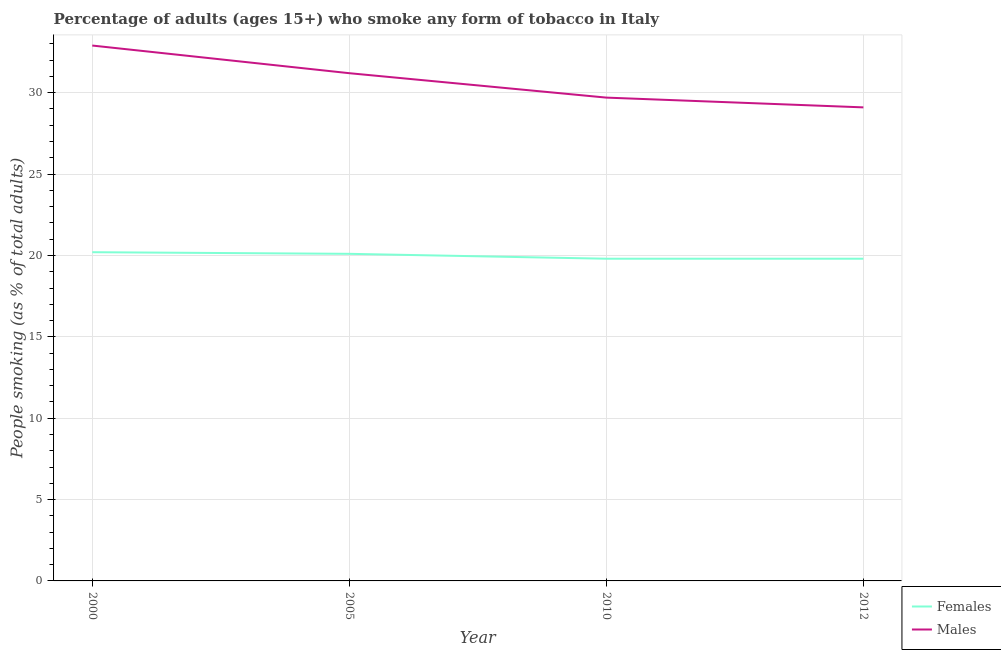How many different coloured lines are there?
Keep it short and to the point. 2. What is the percentage of males who smoke in 2010?
Your answer should be very brief. 29.7. Across all years, what is the maximum percentage of females who smoke?
Keep it short and to the point. 20.2. Across all years, what is the minimum percentage of males who smoke?
Make the answer very short. 29.1. In which year was the percentage of males who smoke maximum?
Offer a terse response. 2000. In which year was the percentage of females who smoke minimum?
Your answer should be compact. 2010. What is the total percentage of males who smoke in the graph?
Provide a succinct answer. 122.9. What is the difference between the percentage of males who smoke in 2000 and that in 2010?
Your answer should be very brief. 3.2. What is the difference between the percentage of males who smoke in 2012 and the percentage of females who smoke in 2000?
Provide a short and direct response. 8.9. What is the average percentage of females who smoke per year?
Offer a very short reply. 19.97. In the year 2010, what is the difference between the percentage of females who smoke and percentage of males who smoke?
Offer a terse response. -9.9. In how many years, is the percentage of males who smoke greater than 9 %?
Provide a short and direct response. 4. What is the difference between the highest and the second highest percentage of males who smoke?
Keep it short and to the point. 1.7. What is the difference between the highest and the lowest percentage of females who smoke?
Provide a short and direct response. 0.4. In how many years, is the percentage of females who smoke greater than the average percentage of females who smoke taken over all years?
Keep it short and to the point. 2. Is the sum of the percentage of males who smoke in 2005 and 2012 greater than the maximum percentage of females who smoke across all years?
Give a very brief answer. Yes. Is the percentage of males who smoke strictly greater than the percentage of females who smoke over the years?
Keep it short and to the point. Yes. Is the percentage of females who smoke strictly less than the percentage of males who smoke over the years?
Give a very brief answer. Yes. How many lines are there?
Your answer should be very brief. 2. What is the difference between two consecutive major ticks on the Y-axis?
Make the answer very short. 5. Are the values on the major ticks of Y-axis written in scientific E-notation?
Offer a terse response. No. Does the graph contain grids?
Provide a succinct answer. Yes. How many legend labels are there?
Offer a very short reply. 2. What is the title of the graph?
Ensure brevity in your answer.  Percentage of adults (ages 15+) who smoke any form of tobacco in Italy. What is the label or title of the Y-axis?
Your response must be concise. People smoking (as % of total adults). What is the People smoking (as % of total adults) in Females in 2000?
Your answer should be very brief. 20.2. What is the People smoking (as % of total adults) in Males in 2000?
Your response must be concise. 32.9. What is the People smoking (as % of total adults) of Females in 2005?
Offer a very short reply. 20.1. What is the People smoking (as % of total adults) in Males in 2005?
Ensure brevity in your answer.  31.2. What is the People smoking (as % of total adults) of Females in 2010?
Keep it short and to the point. 19.8. What is the People smoking (as % of total adults) in Males in 2010?
Your answer should be very brief. 29.7. What is the People smoking (as % of total adults) of Females in 2012?
Ensure brevity in your answer.  19.8. What is the People smoking (as % of total adults) in Males in 2012?
Make the answer very short. 29.1. Across all years, what is the maximum People smoking (as % of total adults) in Females?
Ensure brevity in your answer.  20.2. Across all years, what is the maximum People smoking (as % of total adults) of Males?
Your answer should be compact. 32.9. Across all years, what is the minimum People smoking (as % of total adults) of Females?
Your response must be concise. 19.8. Across all years, what is the minimum People smoking (as % of total adults) in Males?
Keep it short and to the point. 29.1. What is the total People smoking (as % of total adults) of Females in the graph?
Your answer should be compact. 79.9. What is the total People smoking (as % of total adults) of Males in the graph?
Give a very brief answer. 122.9. What is the difference between the People smoking (as % of total adults) in Females in 2000 and that in 2005?
Your response must be concise. 0.1. What is the difference between the People smoking (as % of total adults) in Males in 2000 and that in 2010?
Offer a terse response. 3.2. What is the difference between the People smoking (as % of total adults) in Males in 2000 and that in 2012?
Offer a terse response. 3.8. What is the difference between the People smoking (as % of total adults) of Females in 2005 and that in 2012?
Provide a succinct answer. 0.3. What is the difference between the People smoking (as % of total adults) of Females in 2010 and that in 2012?
Ensure brevity in your answer.  0. What is the difference between the People smoking (as % of total adults) in Females in 2000 and the People smoking (as % of total adults) in Males in 2005?
Your answer should be very brief. -11. What is the difference between the People smoking (as % of total adults) of Females in 2000 and the People smoking (as % of total adults) of Males in 2010?
Keep it short and to the point. -9.5. What is the difference between the People smoking (as % of total adults) in Females in 2010 and the People smoking (as % of total adults) in Males in 2012?
Offer a very short reply. -9.3. What is the average People smoking (as % of total adults) in Females per year?
Make the answer very short. 19.98. What is the average People smoking (as % of total adults) of Males per year?
Make the answer very short. 30.73. In the year 2005, what is the difference between the People smoking (as % of total adults) in Females and People smoking (as % of total adults) in Males?
Your response must be concise. -11.1. In the year 2010, what is the difference between the People smoking (as % of total adults) in Females and People smoking (as % of total adults) in Males?
Ensure brevity in your answer.  -9.9. What is the ratio of the People smoking (as % of total adults) in Males in 2000 to that in 2005?
Your answer should be compact. 1.05. What is the ratio of the People smoking (as % of total adults) of Females in 2000 to that in 2010?
Provide a succinct answer. 1.02. What is the ratio of the People smoking (as % of total adults) of Males in 2000 to that in 2010?
Ensure brevity in your answer.  1.11. What is the ratio of the People smoking (as % of total adults) in Females in 2000 to that in 2012?
Offer a very short reply. 1.02. What is the ratio of the People smoking (as % of total adults) in Males in 2000 to that in 2012?
Give a very brief answer. 1.13. What is the ratio of the People smoking (as % of total adults) in Females in 2005 to that in 2010?
Ensure brevity in your answer.  1.02. What is the ratio of the People smoking (as % of total adults) of Males in 2005 to that in 2010?
Make the answer very short. 1.05. What is the ratio of the People smoking (as % of total adults) of Females in 2005 to that in 2012?
Offer a very short reply. 1.02. What is the ratio of the People smoking (as % of total adults) in Males in 2005 to that in 2012?
Offer a terse response. 1.07. What is the ratio of the People smoking (as % of total adults) in Females in 2010 to that in 2012?
Provide a short and direct response. 1. What is the ratio of the People smoking (as % of total adults) in Males in 2010 to that in 2012?
Provide a succinct answer. 1.02. What is the difference between the highest and the second highest People smoking (as % of total adults) in Males?
Offer a terse response. 1.7. 